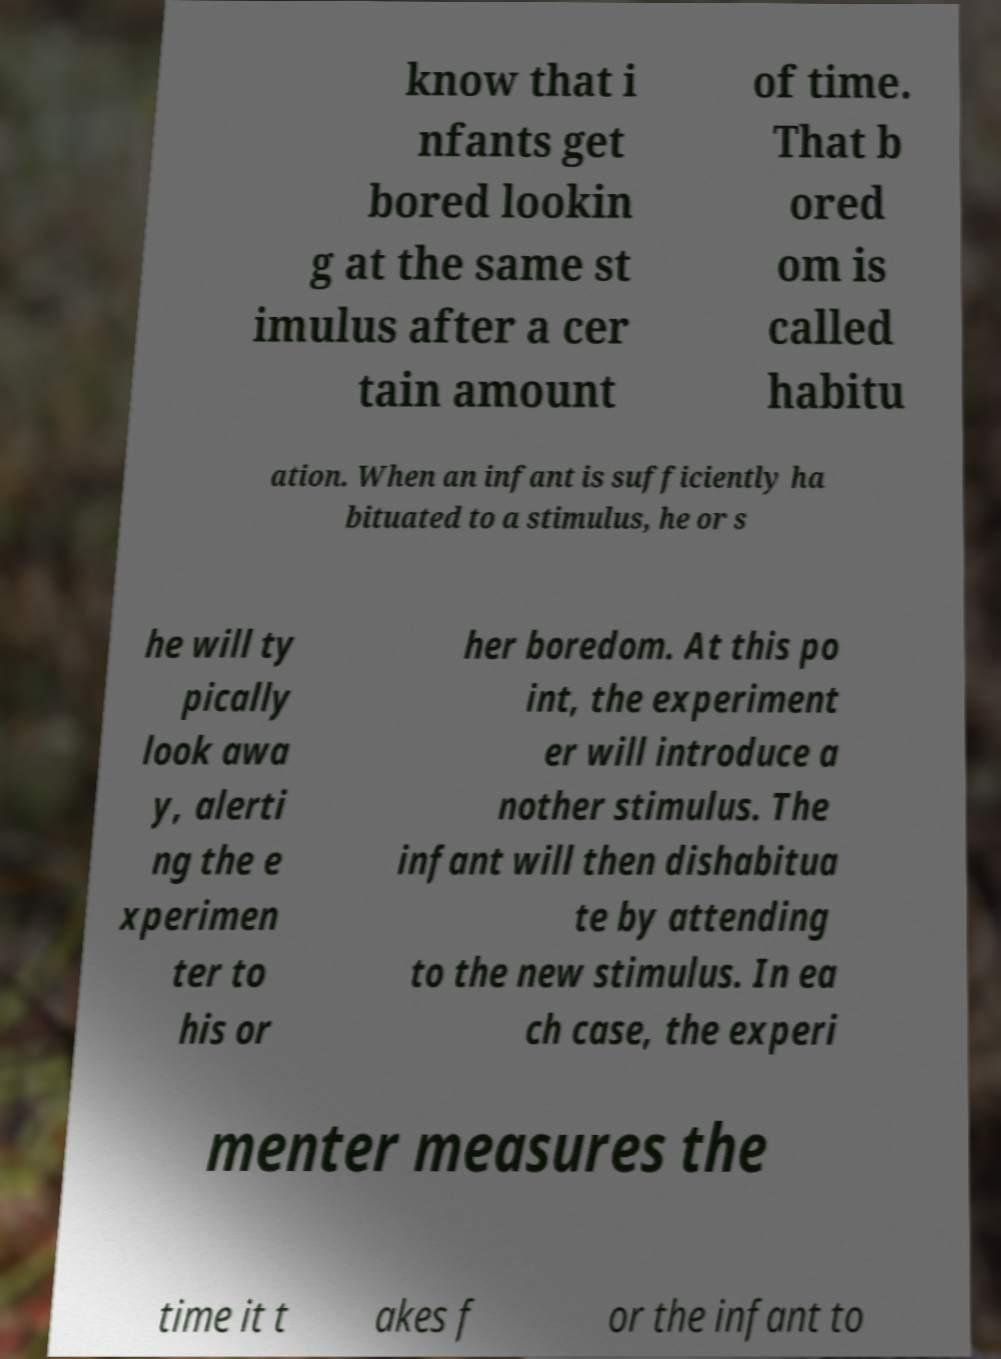Could you assist in decoding the text presented in this image and type it out clearly? know that i nfants get bored lookin g at the same st imulus after a cer tain amount of time. That b ored om is called habitu ation. When an infant is sufficiently ha bituated to a stimulus, he or s he will ty pically look awa y, alerti ng the e xperimen ter to his or her boredom. At this po int, the experiment er will introduce a nother stimulus. The infant will then dishabitua te by attending to the new stimulus. In ea ch case, the experi menter measures the time it t akes f or the infant to 